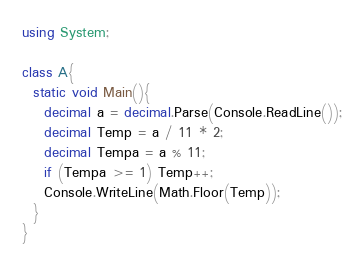Convert code to text. <code><loc_0><loc_0><loc_500><loc_500><_C#_>using System;

class A{
  static void Main(){
    decimal a = decimal.Parse(Console.ReadLine());
    decimal Temp = a / 11 * 2;
    decimal Tempa = a % 11;
    if (Tempa >= 1) Temp++;
    Console.WriteLine(Math.Floor(Temp));
  }
}</code> 